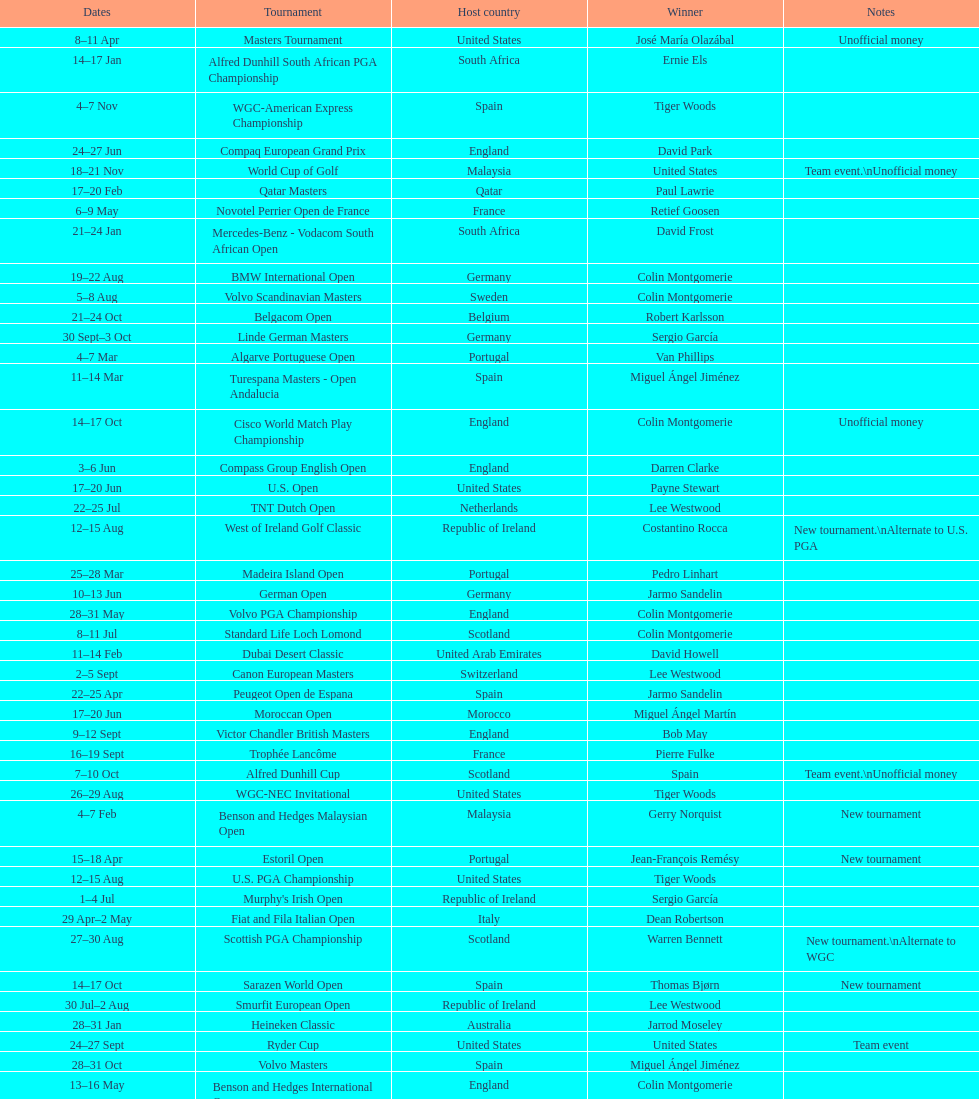How long did the estoril open last? 3 days. 